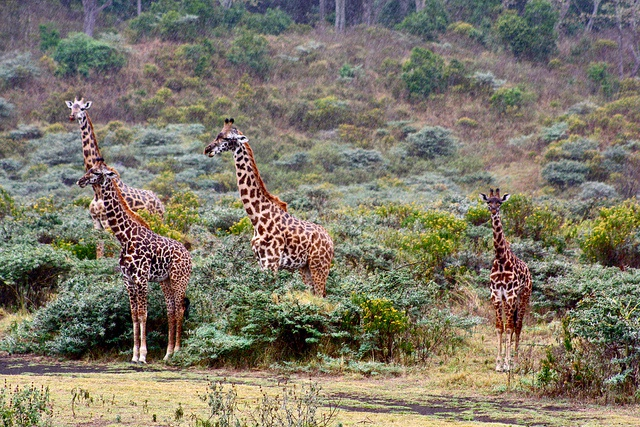Describe the objects in this image and their specific colors. I can see giraffe in black, maroon, brown, and lightpink tones, giraffe in black, maroon, lightpink, brown, and pink tones, giraffe in black, maroon, brown, and lightpink tones, and giraffe in black, gray, darkgray, and lightpink tones in this image. 